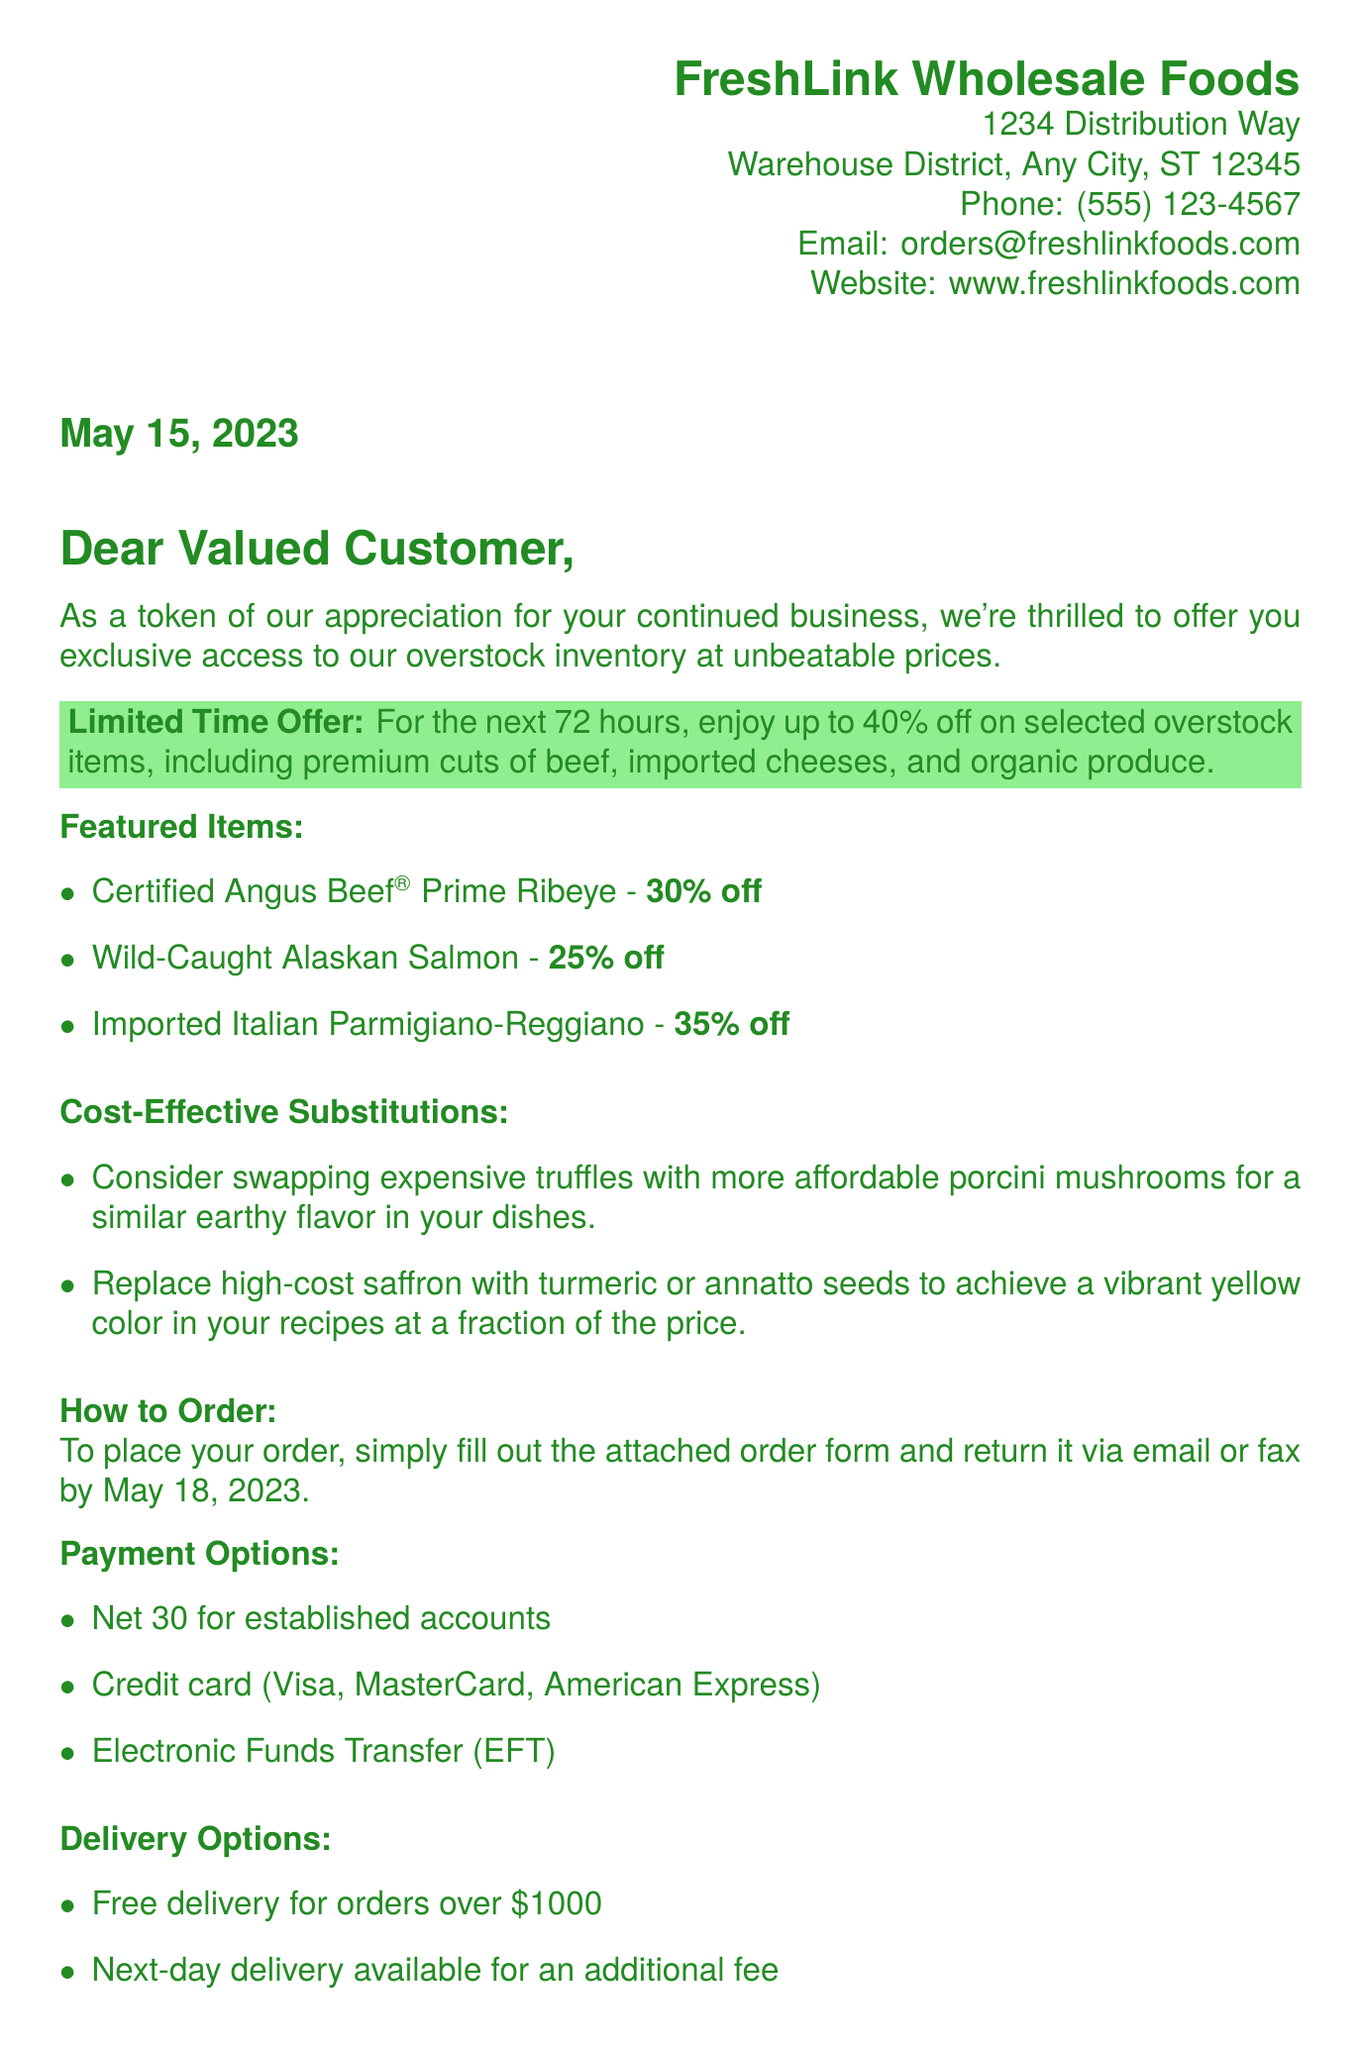What is the name of the company? The company mentioned in the letter is FreshLink Wholesale Foods.
Answer: FreshLink Wholesale Foods What is the address of FreshLink? The address provided in the document is 1234 Distribution Way, Warehouse District, Any City, ST 12345.
Answer: 1234 Distribution Way, Warehouse District, Any City, ST 12345 What is the discount on Certified Angus Beef Prime Ribeye? The discount offered on Certified Angus Beef Prime Ribeye is 30%.
Answer: 30% off When does the special offer end? The special offer ends on May 18, 2023.
Answer: May 18, 2023 What is one cost-effective substitution for saffron? The document suggests replacing high-cost saffron with turmeric or annatto seeds.
Answer: Turmeric or annatto seeds How can orders be submitted? Orders can be submitted by filling out the attached order form and returning it via email or fax.
Answer: Email or fax What is the delivery option for orders over $1000? The delivery option for orders over $1000 is free delivery.
Answer: Free delivery What is the payment option mentioned for established accounts? The payment option for established accounts is Net 30.
Answer: Net 30 What is the phone number for FreshLink Wholesale Foods? The phone number listed is (555) 123-4567.
Answer: (555) 123-4567 